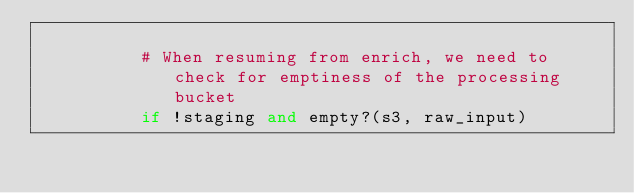<code> <loc_0><loc_0><loc_500><loc_500><_Ruby_>
          # When resuming from enrich, we need to check for emptiness of the processing bucket
          if !staging and empty?(s3, raw_input)</code> 